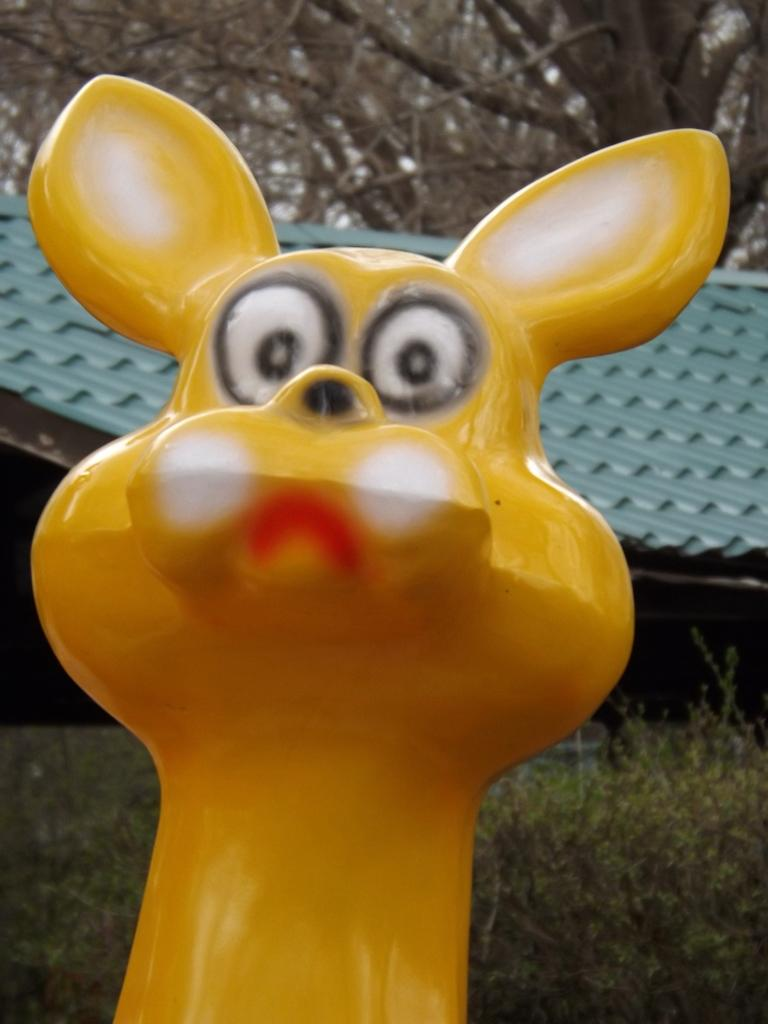What is the main subject in the center of the image? There is a toy in the center of the image. Can you describe the appearance of the toy? The toy has a multi-color appearance. What can be seen in the background of the image? There are trees, grass, and a green-colored wooden object in the background of the image. What type of peace symbol can be seen in the image? There is no peace symbol present in the image. How many roses are visible in the image? There are no roses visible in the image. 